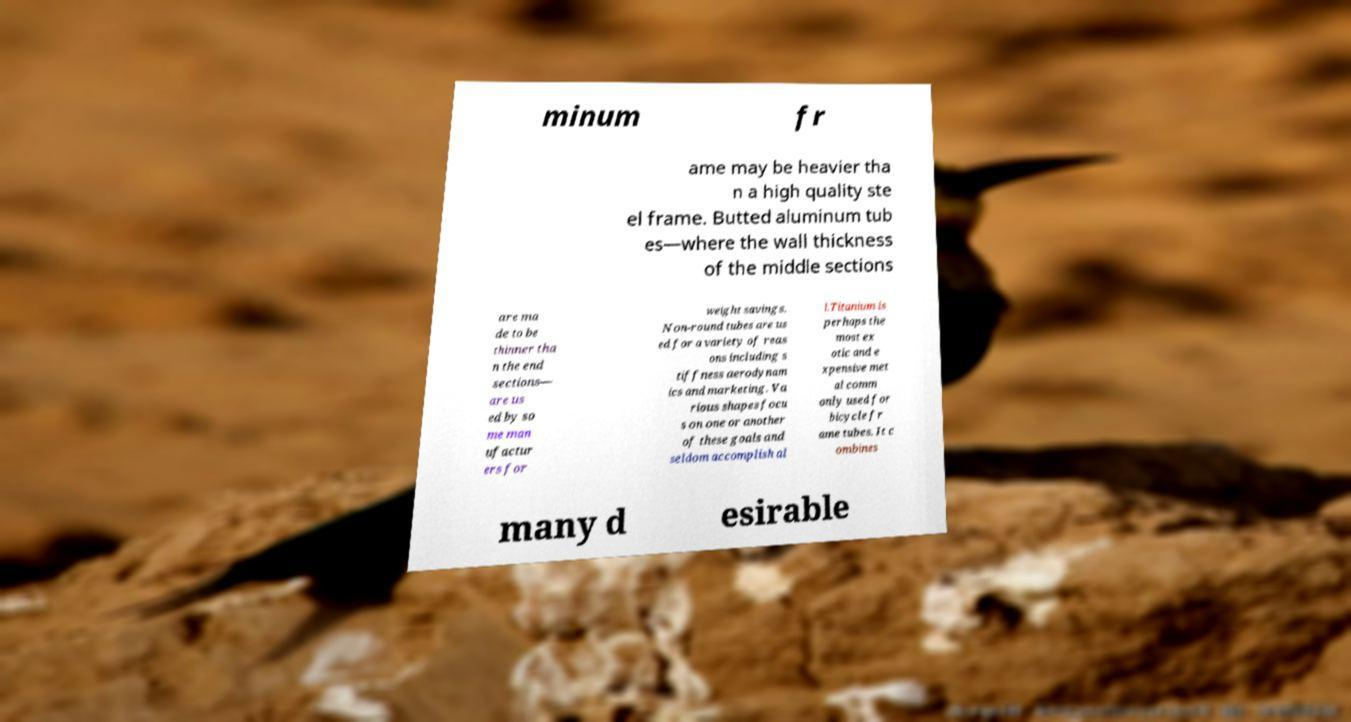There's text embedded in this image that I need extracted. Can you transcribe it verbatim? minum fr ame may be heavier tha n a high quality ste el frame. Butted aluminum tub es—where the wall thickness of the middle sections are ma de to be thinner tha n the end sections— are us ed by so me man ufactur ers for weight savings. Non-round tubes are us ed for a variety of reas ons including s tiffness aerodynam ics and marketing. Va rious shapes focu s on one or another of these goals and seldom accomplish al l.Titanium is perhaps the most ex otic and e xpensive met al comm only used for bicycle fr ame tubes. It c ombines many d esirable 